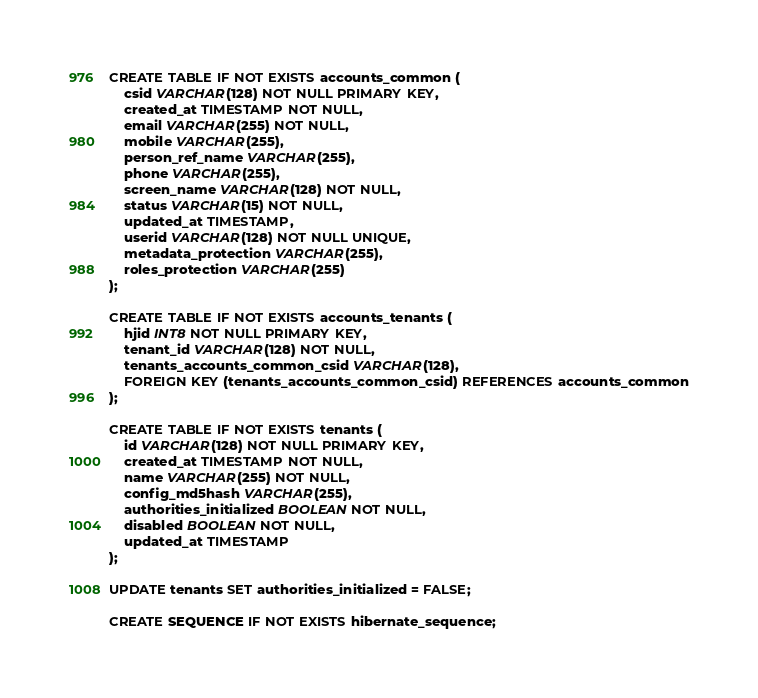<code> <loc_0><loc_0><loc_500><loc_500><_SQL_>CREATE TABLE IF NOT EXISTS accounts_common (
	csid VARCHAR(128) NOT NULL PRIMARY KEY,
	created_at TIMESTAMP NOT NULL,
	email VARCHAR(255) NOT NULL,
	mobile VARCHAR(255),
	person_ref_name VARCHAR(255),
	phone VARCHAR(255),
	screen_name VARCHAR(128) NOT NULL,
	status VARCHAR(15) NOT NULL,
	updated_at TIMESTAMP,
	userid VARCHAR(128) NOT NULL UNIQUE,
	metadata_protection VARCHAR(255),
	roles_protection VARCHAR(255)
);

CREATE TABLE IF NOT EXISTS accounts_tenants (
	hjid INT8 NOT NULL PRIMARY KEY,
	tenant_id VARCHAR(128) NOT NULL,
	tenants_accounts_common_csid VARCHAR(128),
	FOREIGN KEY (tenants_accounts_common_csid) REFERENCES accounts_common
);

CREATE TABLE IF NOT EXISTS tenants (
	id VARCHAR(128) NOT NULL PRIMARY KEY,
	created_at TIMESTAMP NOT NULL,
	name VARCHAR(255) NOT NULL,
	config_md5hash VARCHAR(255),
	authorities_initialized BOOLEAN NOT NULL,
	disabled BOOLEAN NOT NULL,
	updated_at TIMESTAMP
);

UPDATE tenants SET authorities_initialized = FALSE;

CREATE SEQUENCE IF NOT EXISTS hibernate_sequence;
</code> 